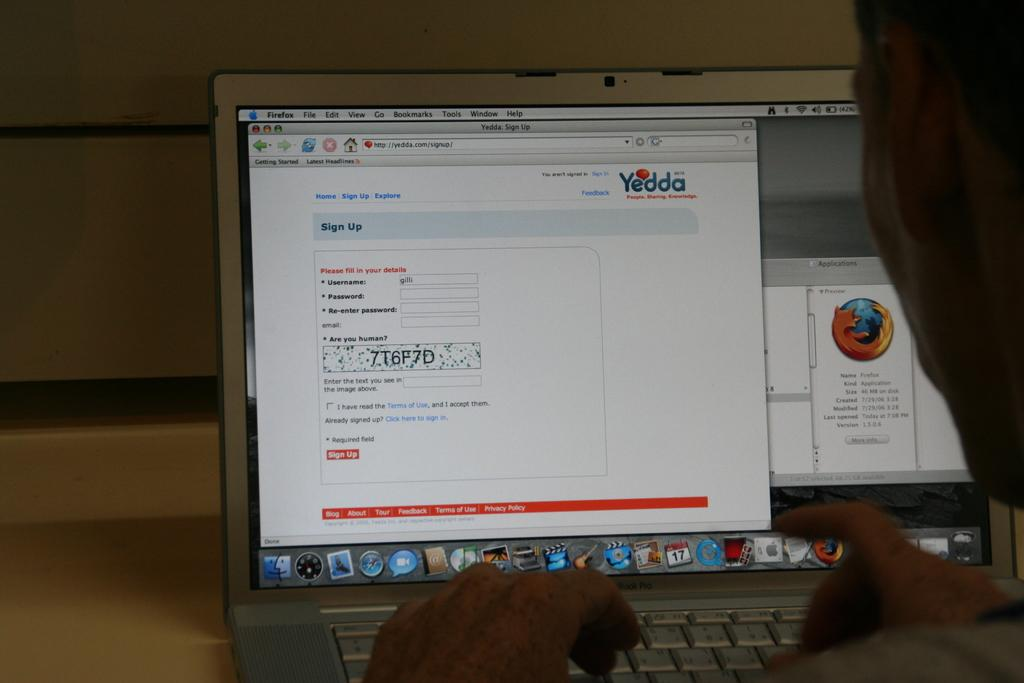<image>
Create a compact narrative representing the image presented. The sign up page on Yedda to create an account. 